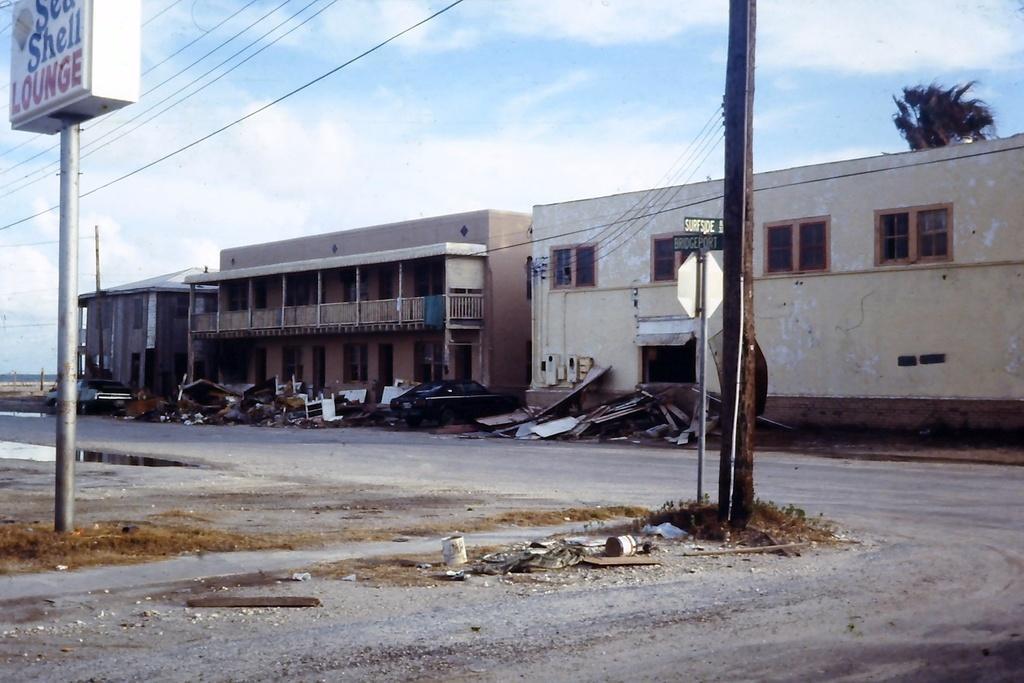Describe this image in one or two sentences. In this picture we can see two poles in the front, on the left side there is a board, in the background there are buildings and a tree, there is a car in the middle, we can see the sky and wires at the top of the picture. 